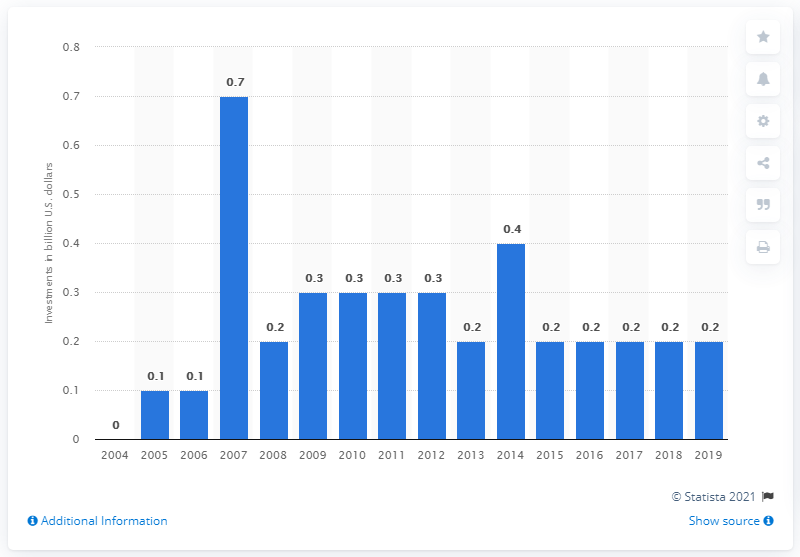Draw attention to some important aspects in this diagram. According to estimates, the world invested approximately 0.2% of its gross domestic product in ocean energy technologies in 2019. According to estimates, the world invested approximately 0.2 billion US dollars in ocean energy technologies in 2019. In 2014, the world invested approximately 0.4 billion in ocean energy technologies. 